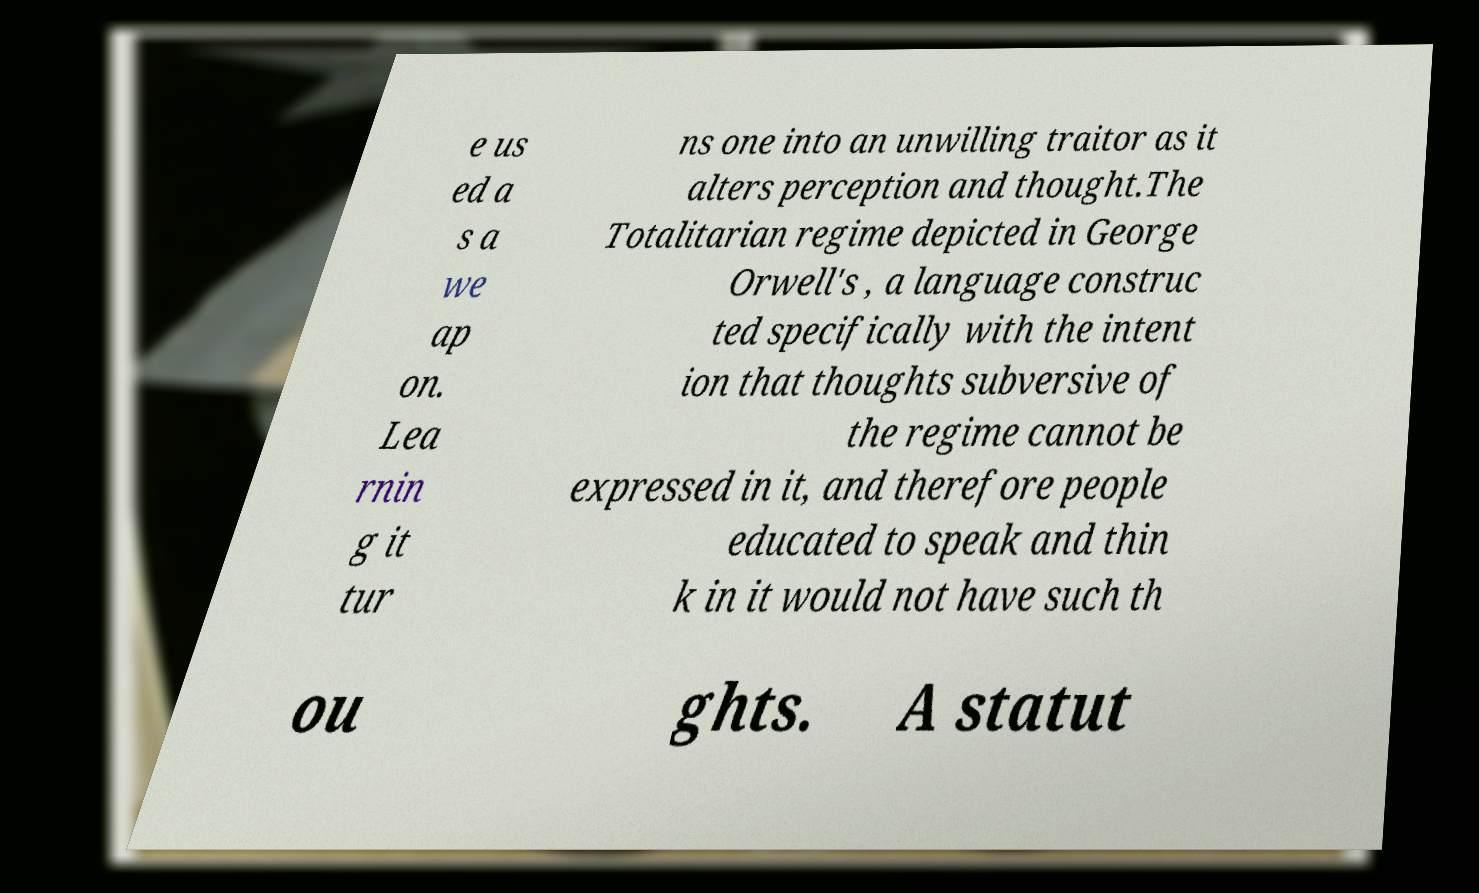Could you assist in decoding the text presented in this image and type it out clearly? e us ed a s a we ap on. Lea rnin g it tur ns one into an unwilling traitor as it alters perception and thought.The Totalitarian regime depicted in George Orwell's , a language construc ted specifically with the intent ion that thoughts subversive of the regime cannot be expressed in it, and therefore people educated to speak and thin k in it would not have such th ou ghts. A statut 